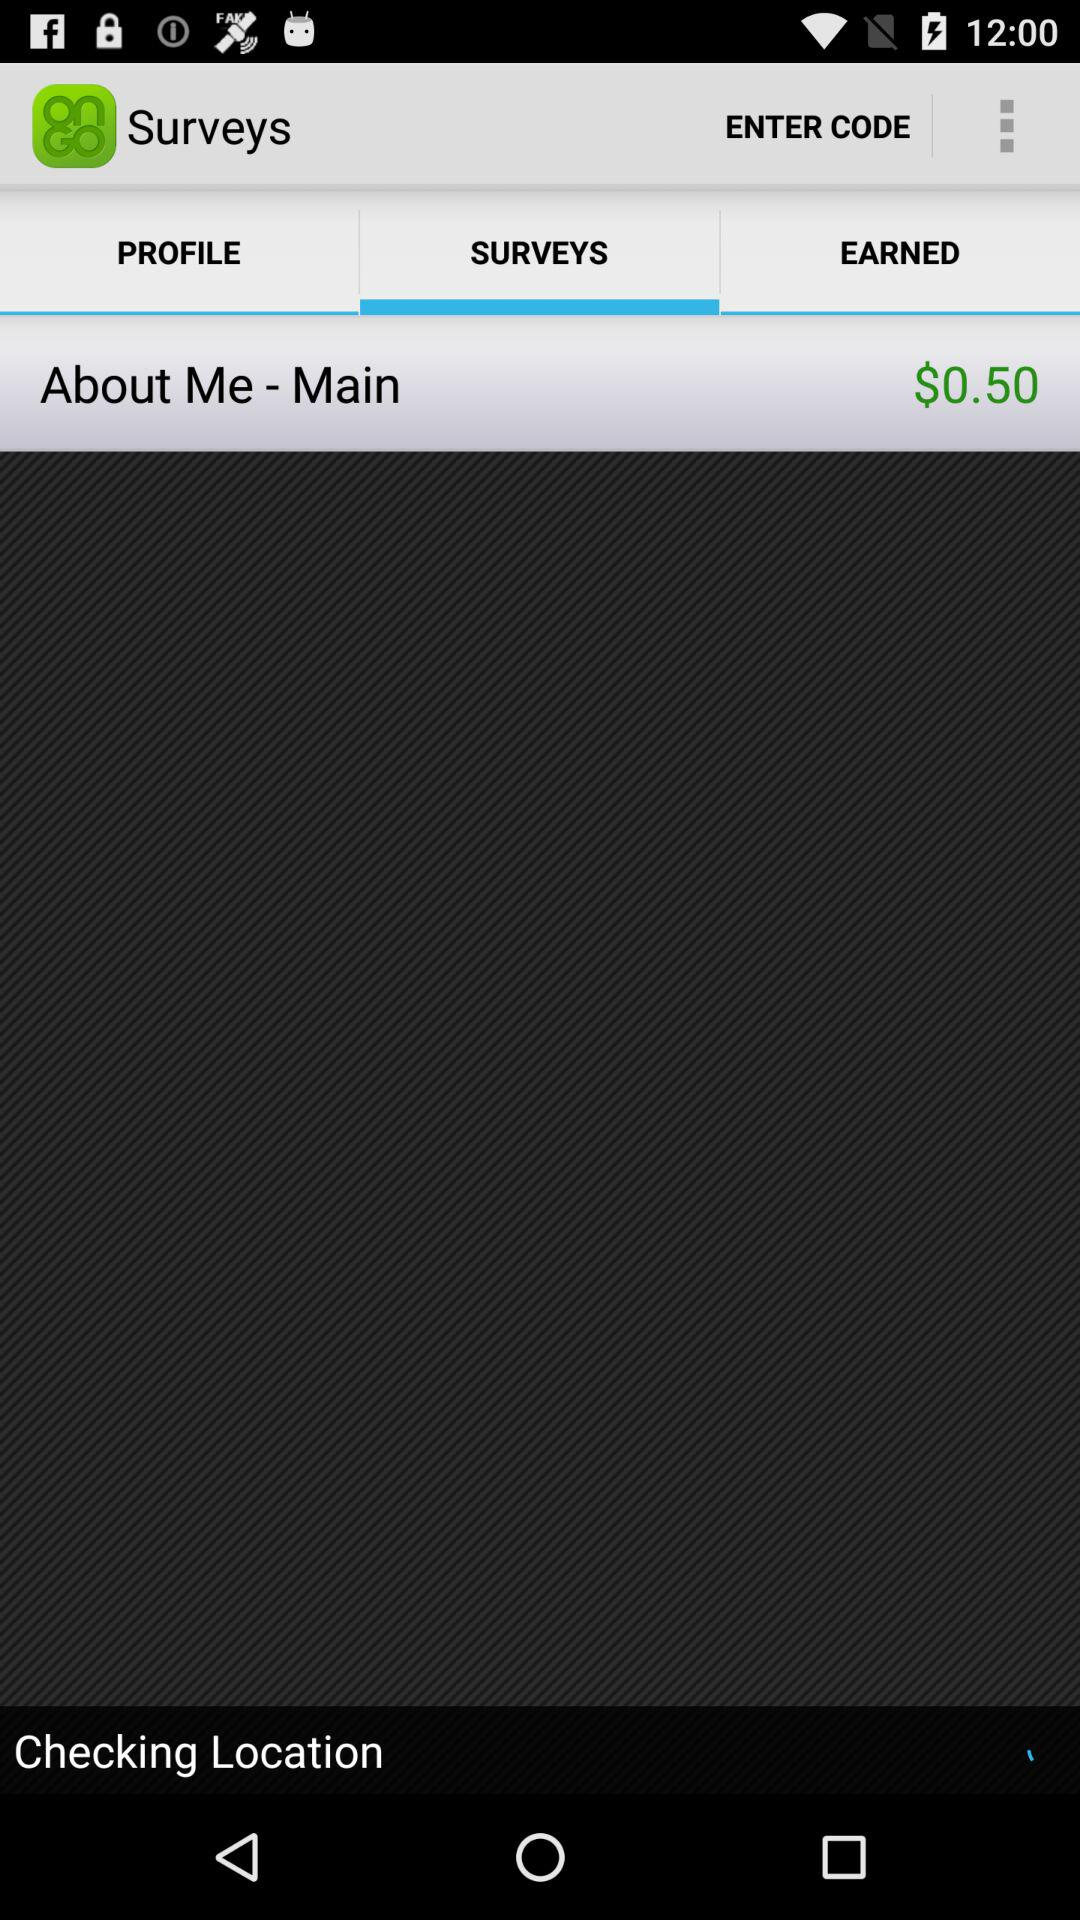What is the name of the application? The name of the application is "Surveys On The Go". 